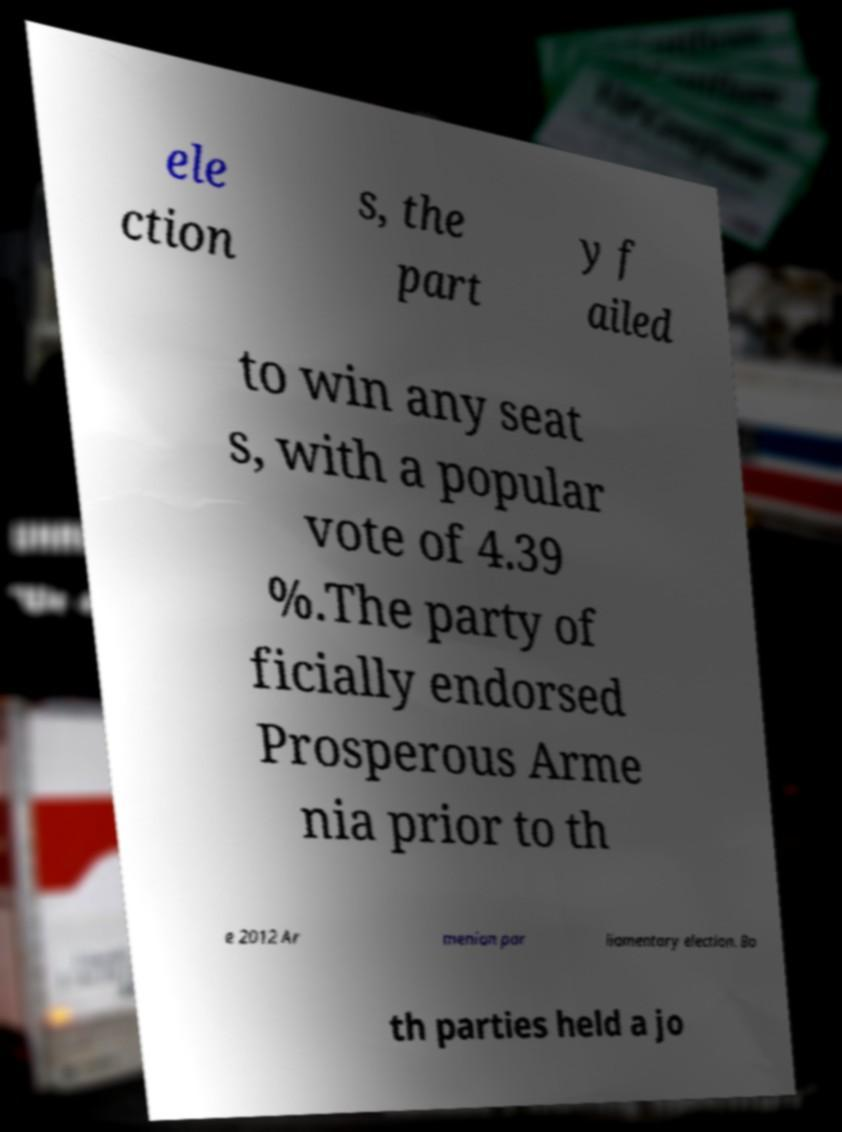Can you read and provide the text displayed in the image?This photo seems to have some interesting text. Can you extract and type it out for me? ele ction s, the part y f ailed to win any seat s, with a popular vote of 4.39 %.The party of ficially endorsed Prosperous Arme nia prior to th e 2012 Ar menian par liamentary election. Bo th parties held a jo 